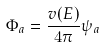<formula> <loc_0><loc_0><loc_500><loc_500>\Phi _ { a } = \frac { v ( E ) } { 4 \pi } \psi _ { a }</formula> 